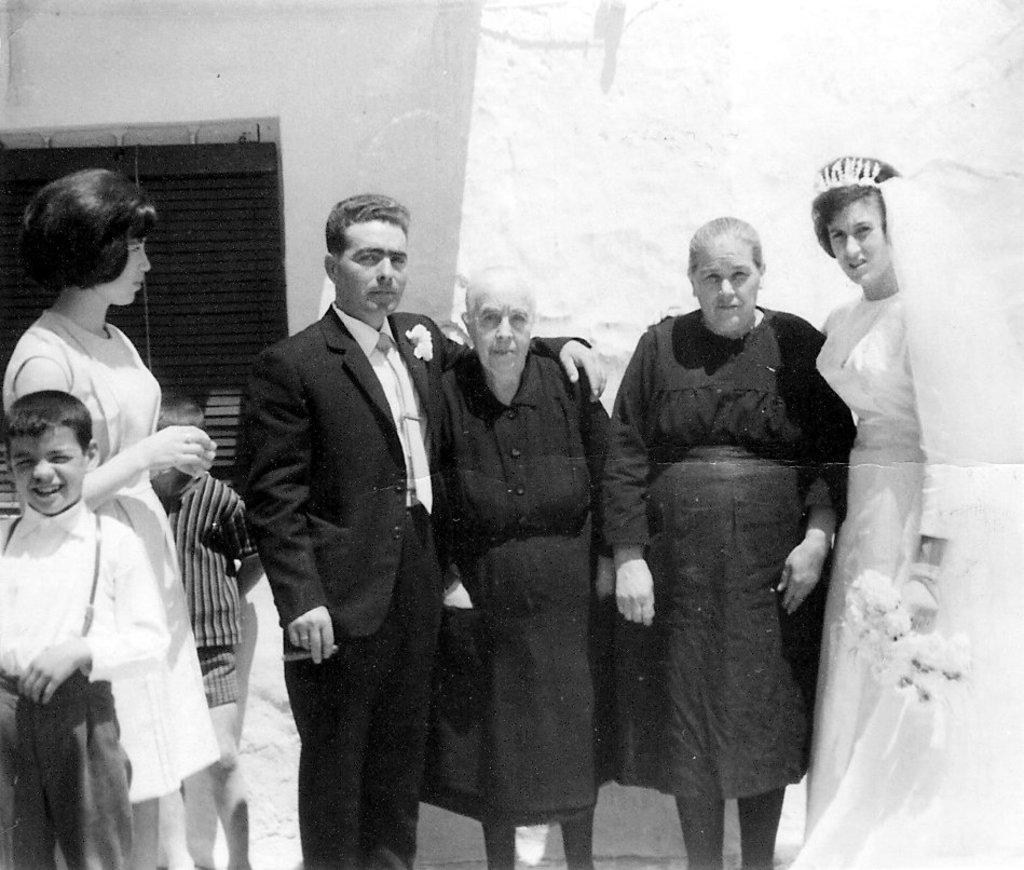What is the color scheme of the image? The image is black and white. What can be seen in the foreground of the image? There is a group of people standing in the image. What is visible in the background of the image? There is a wall and a window in the background of the image. What type of punishment is being handed out in the image? There is no indication of punishment in the image; it features a group of people standing in front of a wall and a window. 